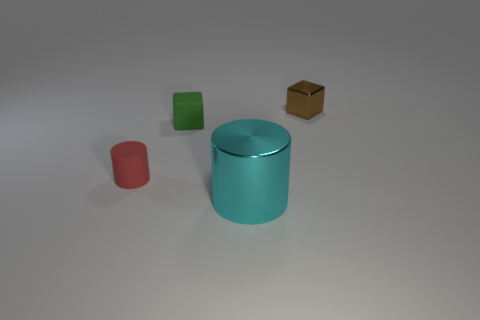What can you tell me about the smallest object? The smallest object appears to be a minuscule speck to the right of the green block - its exact nature is indistinguishable, but it seems to be white or light gray, potentially a small piece of debris or a flaw in the image. How do you think that tiny object ended up there? It's hard to say for sure without more context, but it might have been placed there deliberately as part of a design, or it could have accidentally fallen near the green block if the setting was a physical space. In a digital image, it could simply be an artifact from rendering. 